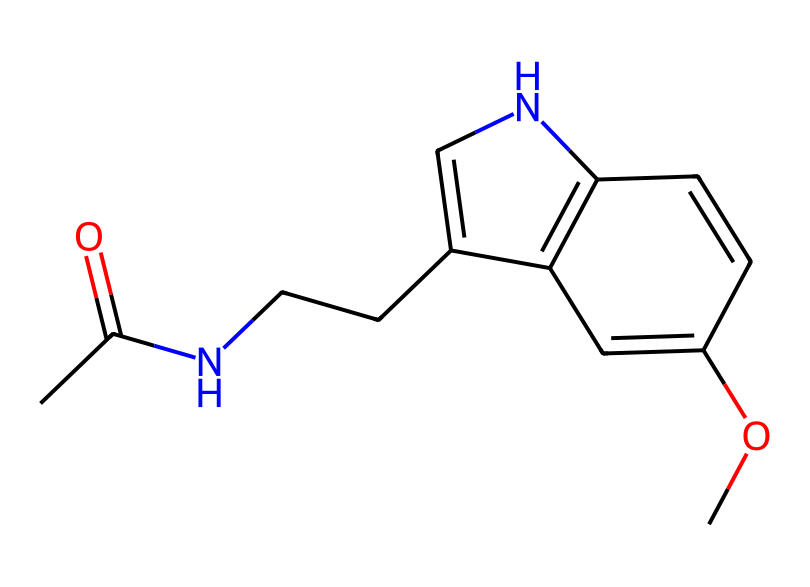What is the molecular formula of this chemical? To determine the molecular formula, count the number of each type of atom in the chemical structure. From the provided SMILES representation, we identify 12 carbon (C) atoms, 15 hydrogen (H) atoms, 1 nitrogen (N) atom, and 3 oxygen (O) atoms. Thus, the molecular formula is C13H16N2O3.
Answer: C13H16N2O3 How many rings are present in this chemical structure? By examining the chemical structure according to the SMILES representation, we can identify the presence of two cyclic structures. This is indicated by the 'C1' and 'C2' within the SMILES, which denote the starting and ending points of the rings.
Answer: 2 What type of drug category does melatonin belong to? Melatonin is a hormone that regulates sleep-wake cycles, making it classified as a sleep aid or a chronobiotic. This classification is based on its primary biological function.
Answer: sleep aid Identify a functional group present in this chemical. In the chemical structure, the presence of the carbonyl group (C=O) is identified, which is characterized by a carbon atom double-bonded to an oxygen atom. This group is part of the molecular structure of melatonin.
Answer: carbonyl group What is the overall charge of the molecule? Analyzing the molecule's structure as represented by the SMILES, we see that there are no charged atoms (like positively charged ammonium or negatively charged carboxylate). Thus, the molecule is neutral.
Answer: neutral Is there an ether group in this structure? The ether group is characterized by the presence of an oxygen atom connected to two carbon atoms (R-O-R'). By reviewing the given chemical structure, we find an -O- linkage between carbon atoms, indicating the presence of an ether bond in the structure.
Answer: yes 